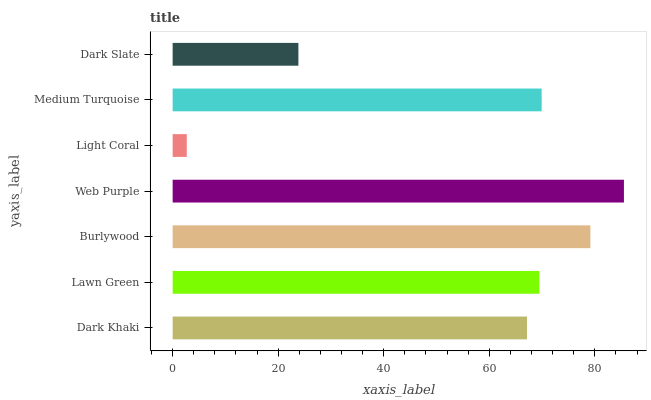Is Light Coral the minimum?
Answer yes or no. Yes. Is Web Purple the maximum?
Answer yes or no. Yes. Is Lawn Green the minimum?
Answer yes or no. No. Is Lawn Green the maximum?
Answer yes or no. No. Is Lawn Green greater than Dark Khaki?
Answer yes or no. Yes. Is Dark Khaki less than Lawn Green?
Answer yes or no. Yes. Is Dark Khaki greater than Lawn Green?
Answer yes or no. No. Is Lawn Green less than Dark Khaki?
Answer yes or no. No. Is Lawn Green the high median?
Answer yes or no. Yes. Is Lawn Green the low median?
Answer yes or no. Yes. Is Dark Slate the high median?
Answer yes or no. No. Is Dark Khaki the low median?
Answer yes or no. No. 